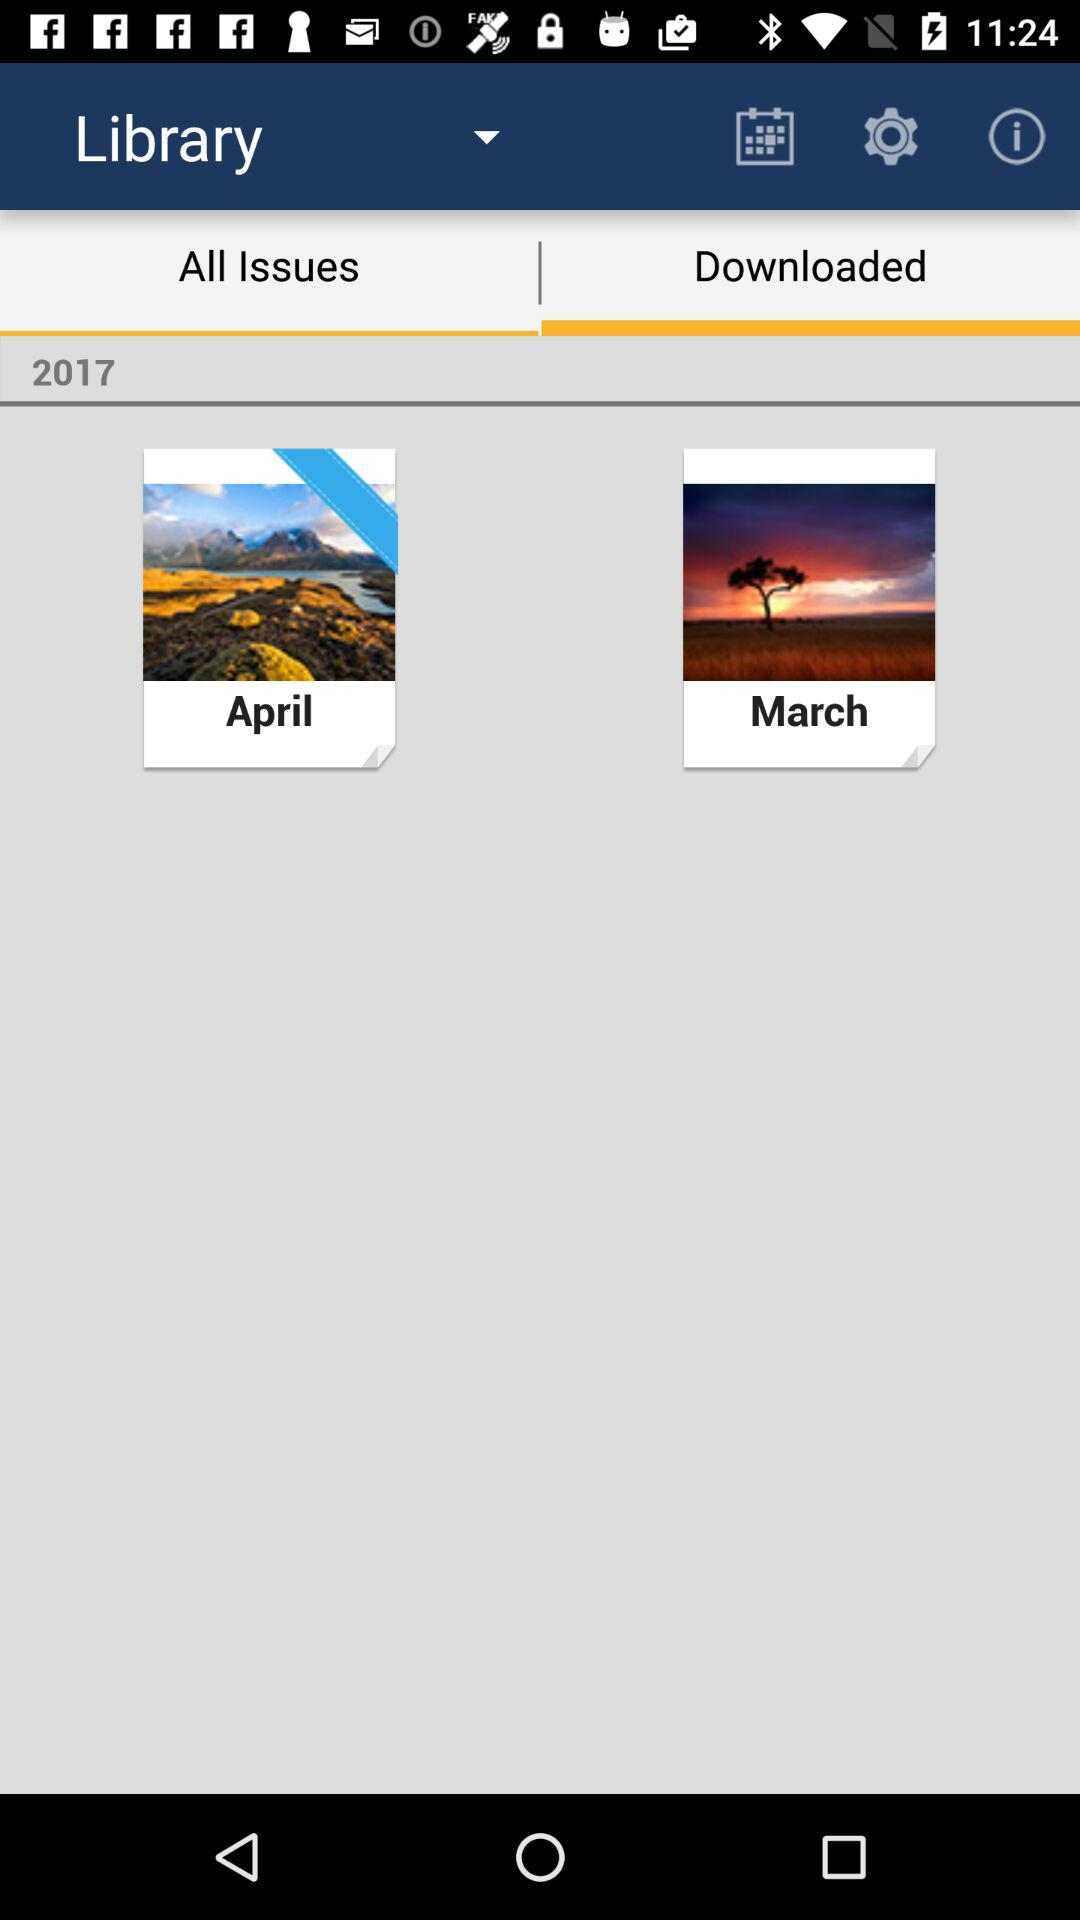What is the year? The year is 2017. 